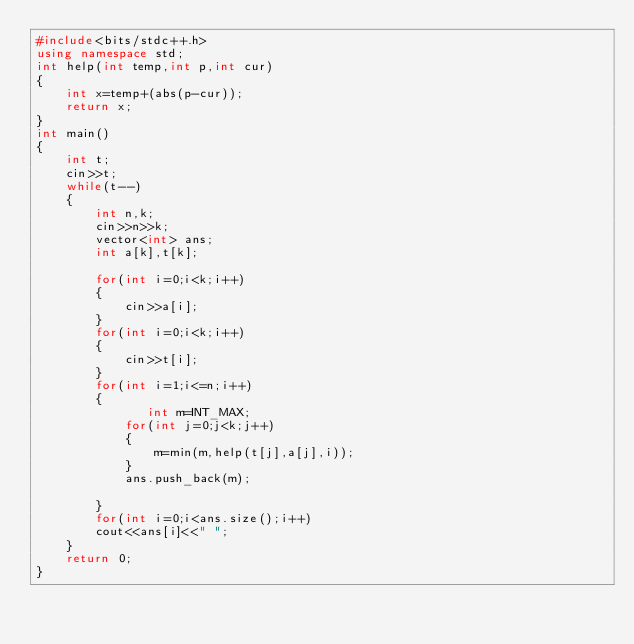Convert code to text. <code><loc_0><loc_0><loc_500><loc_500><_C++_>#include<bits/stdc++.h>
using namespace std;
int help(int temp,int p,int cur)
{
    int x=temp+(abs(p-cur));
    return x;
}
int main()
{
    int t;
    cin>>t;
    while(t--)
    {
        int n,k;
        cin>>n>>k;
        vector<int> ans;
        int a[k],t[k];
     
        for(int i=0;i<k;i++)
        {
            cin>>a[i];
        }
        for(int i=0;i<k;i++)
        {
            cin>>t[i];
        }
        for(int i=1;i<=n;i++)
        {
               int m=INT_MAX;
            for(int j=0;j<k;j++)
            {
                m=min(m,help(t[j],a[j],i));
            }
            ans.push_back(m);

        }
        for(int i=0;i<ans.size();i++)
        cout<<ans[i]<<" ";
    }
    return 0;
}</code> 